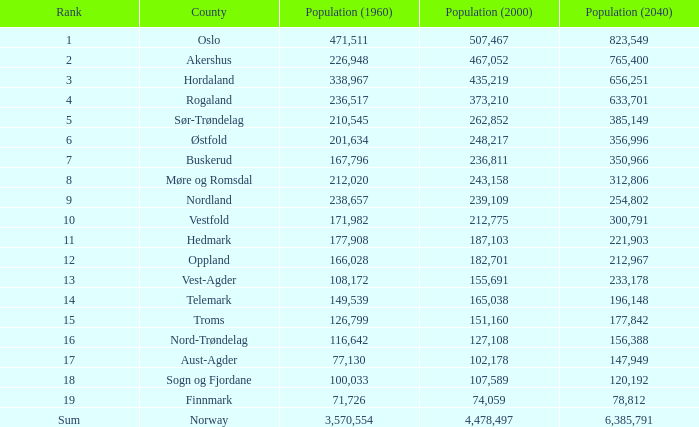What was Oslo's population in 1960, with a population of 507,467 in 2000? None. 